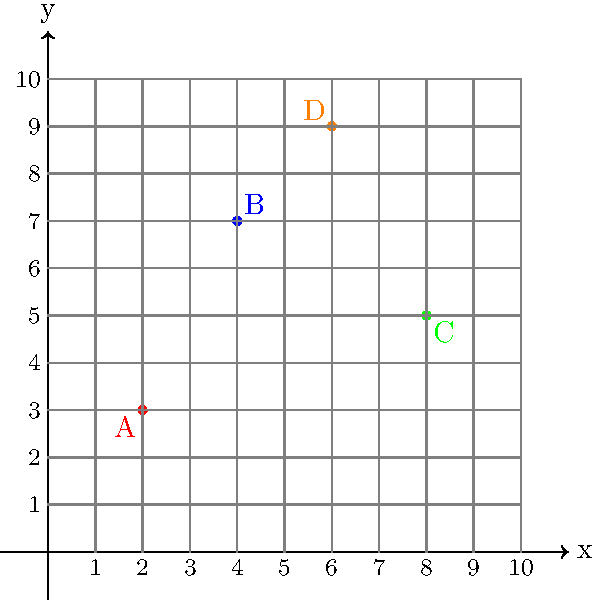A headhunter is analyzing the geographic distribution of four law firms in a city. The locations of these firms are plotted on a coordinate plane, where each unit represents 1 mile. Firm A is located at (2,3), Firm B at (4,7), Firm C at (8,5), and Firm D at (6,9). What is the Manhattan distance between the two firms that are farthest apart? To solve this problem, we need to follow these steps:

1) First, recall that Manhattan distance is calculated as the sum of the absolute differences of the x and y coordinates: $|x_2 - x_1| + |y_2 - y_1|$

2) We need to calculate the Manhattan distance between each pair of firms and find the largest:

   A to B: $|4-2| + |7-3| = 2 + 4 = 6$
   A to C: $|8-2| + |5-3| = 6 + 2 = 8$
   A to D: $|6-2| + |9-3| = 4 + 6 = 10$
   B to C: $|8-4| + |5-7| = 4 + 2 = 6$
   B to D: $|6-4| + |9-7| = 2 + 2 = 4$
   C to D: $|6-8| + |9-5| = 2 + 4 = 6$

3) The largest Manhattan distance is between Firm A and Firm D, which is 10 miles.

This analysis helps the headhunter understand the geographic spread of the law firms, which could be useful in discussions about commute times, client accessibility, or potential relocations.
Answer: 10 miles 